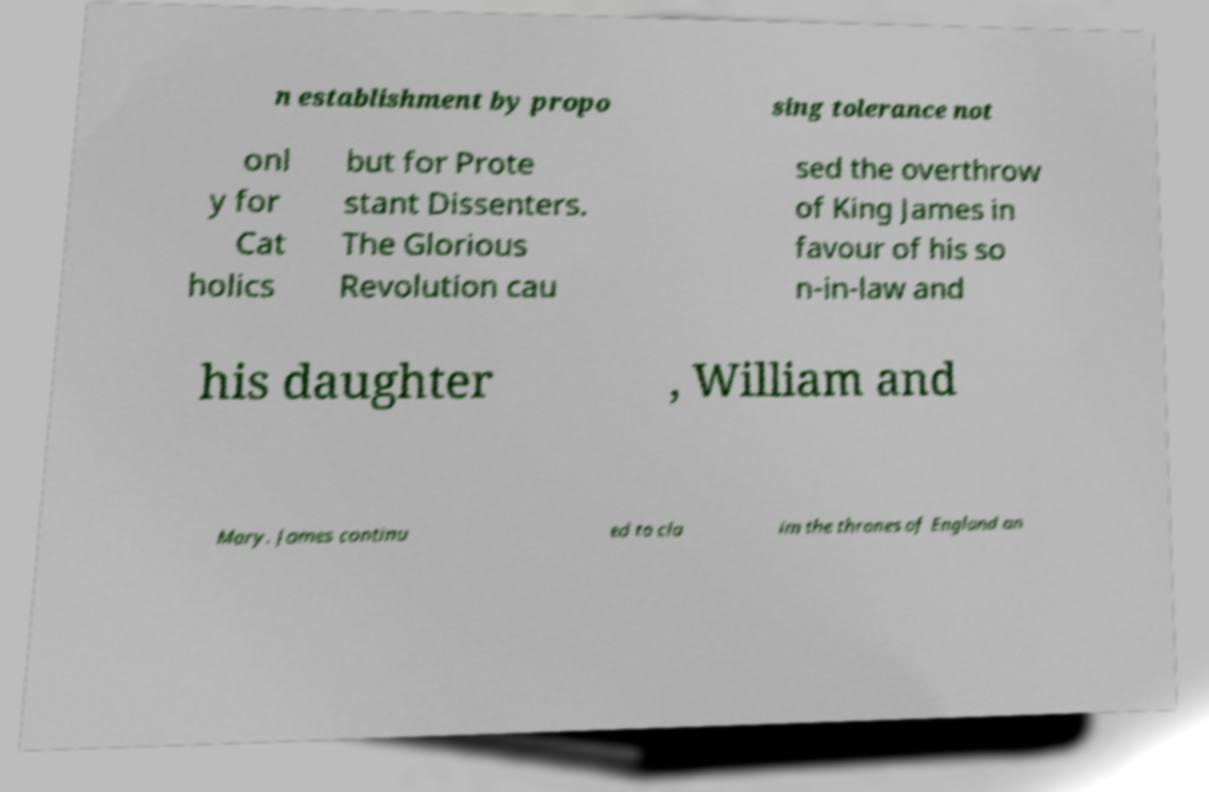For documentation purposes, I need the text within this image transcribed. Could you provide that? n establishment by propo sing tolerance not onl y for Cat holics but for Prote stant Dissenters. The Glorious Revolution cau sed the overthrow of King James in favour of his so n-in-law and his daughter , William and Mary. James continu ed to cla im the thrones of England an 